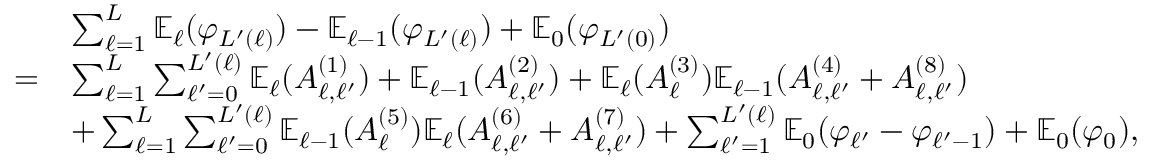<formula> <loc_0><loc_0><loc_500><loc_500>\begin{array} { r l } & { \sum _ { \ell = 1 } ^ { L } \mathbb { E } _ { \ell } ( \varphi _ { L ^ { \prime } ( \ell ) } ) - \mathbb { E } _ { \ell - 1 } ( \varphi _ { L ^ { \prime } ( \ell ) } ) + \mathbb { E } _ { 0 } ( \varphi _ { L ^ { \prime } ( 0 ) } ) } \\ { = } & { \sum _ { \ell = 1 } ^ { L } \sum _ { \ell ^ { \prime } = 0 } ^ { L ^ { \prime } ( \ell ) } \mathbb { E } _ { \ell } ( A _ { \ell , \ell ^ { \prime } } ^ { ( 1 ) } ) + \mathbb { E } _ { \ell - 1 } ( A _ { \ell , \ell ^ { \prime } } ^ { ( 2 ) } ) + \mathbb { E } _ { \ell } ( A _ { \ell } ^ { ( 3 ) } ) \mathbb { E } _ { \ell - 1 } ( A _ { \ell , \ell ^ { \prime } } ^ { ( 4 ) } + A _ { \ell , \ell ^ { \prime } } ^ { ( 8 ) } ) } \\ & { + \sum _ { \ell = 1 } ^ { L } \sum _ { \ell ^ { \prime } = 0 } ^ { L ^ { \prime } ( \ell ) } \mathbb { E } _ { \ell - 1 } ( A _ { \ell } ^ { ( 5 ) } ) \mathbb { E } _ { \ell } ( A _ { \ell , \ell ^ { \prime } } ^ { ( 6 ) } + A _ { \ell , \ell ^ { \prime } } ^ { ( 7 ) } ) + \sum _ { \ell ^ { \prime } = 1 } ^ { L ^ { \prime } ( \ell ) } \mathbb { E } _ { 0 } ( \varphi _ { \ell ^ { \prime } } - \varphi _ { \ell ^ { \prime } - 1 } ) + \mathbb { E } _ { 0 } ( \varphi _ { 0 } ) , } \end{array}</formula> 